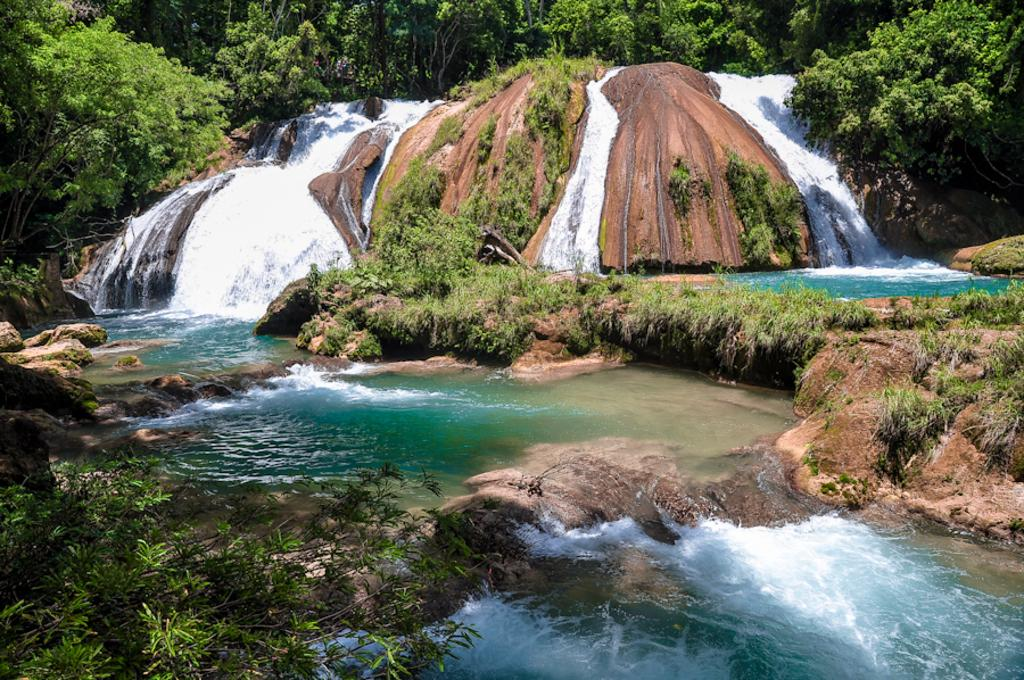What is visible at the bottom of the image? There is water and stones visible at the bottom of the image. What can be seen in the middle of the image? There is a waterfall and trees present in the middle of the image. Can you tell me how many celery stalks are growing in the field in the image? There is no field or celery present in the image; it features a waterfall and trees. What type of brake system is installed on the waterfall in the image? There is no brake system present in the image, as it is a natural waterfall. 